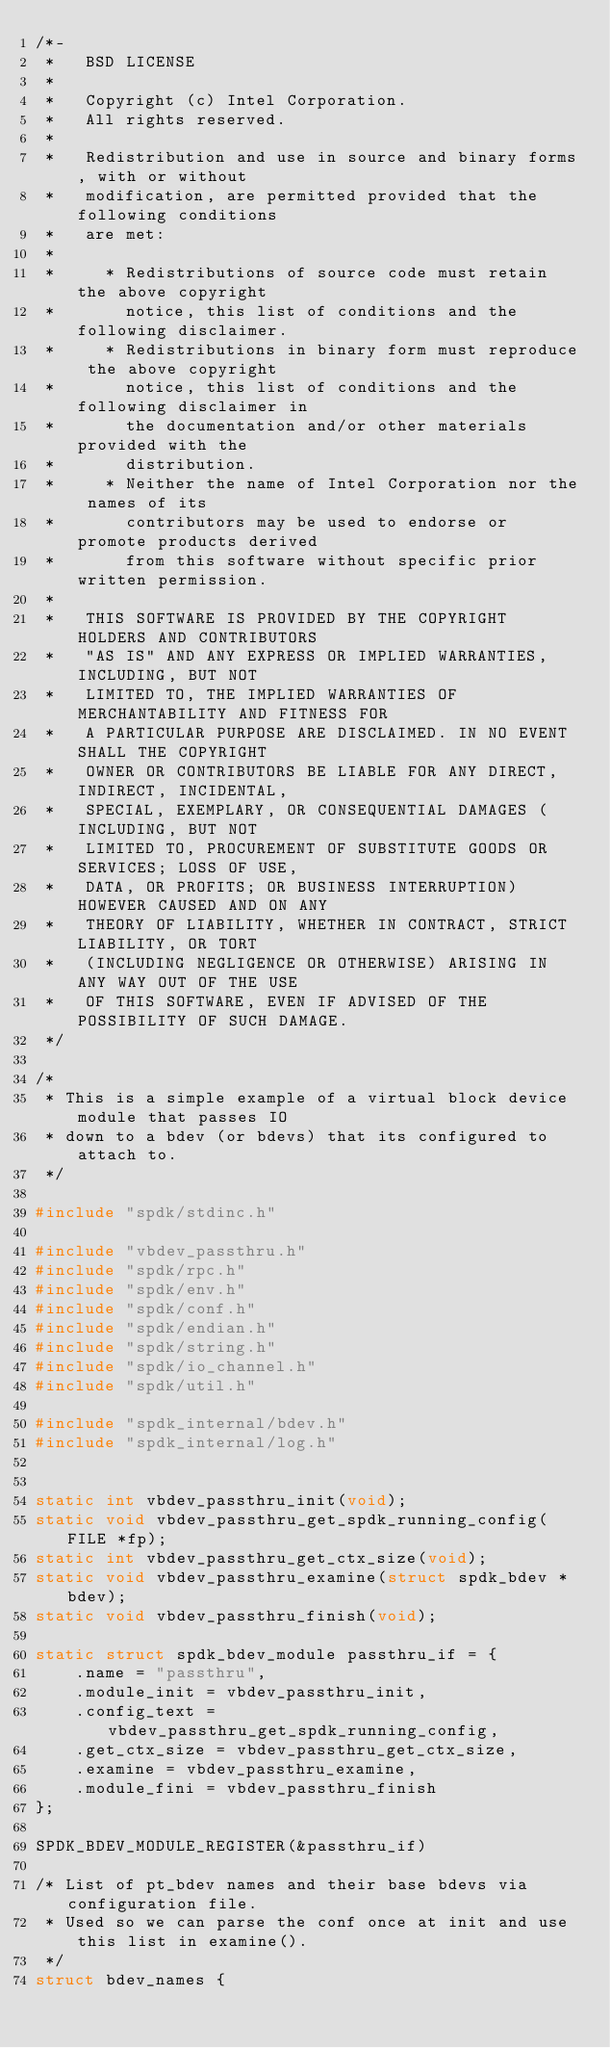Convert code to text. <code><loc_0><loc_0><loc_500><loc_500><_C_>/*-
 *   BSD LICENSE
 *
 *   Copyright (c) Intel Corporation.
 *   All rights reserved.
 *
 *   Redistribution and use in source and binary forms, with or without
 *   modification, are permitted provided that the following conditions
 *   are met:
 *
 *     * Redistributions of source code must retain the above copyright
 *       notice, this list of conditions and the following disclaimer.
 *     * Redistributions in binary form must reproduce the above copyright
 *       notice, this list of conditions and the following disclaimer in
 *       the documentation and/or other materials provided with the
 *       distribution.
 *     * Neither the name of Intel Corporation nor the names of its
 *       contributors may be used to endorse or promote products derived
 *       from this software without specific prior written permission.
 *
 *   THIS SOFTWARE IS PROVIDED BY THE COPYRIGHT HOLDERS AND CONTRIBUTORS
 *   "AS IS" AND ANY EXPRESS OR IMPLIED WARRANTIES, INCLUDING, BUT NOT
 *   LIMITED TO, THE IMPLIED WARRANTIES OF MERCHANTABILITY AND FITNESS FOR
 *   A PARTICULAR PURPOSE ARE DISCLAIMED. IN NO EVENT SHALL THE COPYRIGHT
 *   OWNER OR CONTRIBUTORS BE LIABLE FOR ANY DIRECT, INDIRECT, INCIDENTAL,
 *   SPECIAL, EXEMPLARY, OR CONSEQUENTIAL DAMAGES (INCLUDING, BUT NOT
 *   LIMITED TO, PROCUREMENT OF SUBSTITUTE GOODS OR SERVICES; LOSS OF USE,
 *   DATA, OR PROFITS; OR BUSINESS INTERRUPTION) HOWEVER CAUSED AND ON ANY
 *   THEORY OF LIABILITY, WHETHER IN CONTRACT, STRICT LIABILITY, OR TORT
 *   (INCLUDING NEGLIGENCE OR OTHERWISE) ARISING IN ANY WAY OUT OF THE USE
 *   OF THIS SOFTWARE, EVEN IF ADVISED OF THE POSSIBILITY OF SUCH DAMAGE.
 */

/*
 * This is a simple example of a virtual block device module that passes IO
 * down to a bdev (or bdevs) that its configured to attach to.
 */

#include "spdk/stdinc.h"

#include "vbdev_passthru.h"
#include "spdk/rpc.h"
#include "spdk/env.h"
#include "spdk/conf.h"
#include "spdk/endian.h"
#include "spdk/string.h"
#include "spdk/io_channel.h"
#include "spdk/util.h"

#include "spdk_internal/bdev.h"
#include "spdk_internal/log.h"


static int vbdev_passthru_init(void);
static void vbdev_passthru_get_spdk_running_config(FILE *fp);
static int vbdev_passthru_get_ctx_size(void);
static void vbdev_passthru_examine(struct spdk_bdev *bdev);
static void vbdev_passthru_finish(void);

static struct spdk_bdev_module passthru_if = {
	.name = "passthru",
	.module_init = vbdev_passthru_init,
	.config_text = vbdev_passthru_get_spdk_running_config,
	.get_ctx_size = vbdev_passthru_get_ctx_size,
	.examine = vbdev_passthru_examine,
	.module_fini = vbdev_passthru_finish
};

SPDK_BDEV_MODULE_REGISTER(&passthru_if)

/* List of pt_bdev names and their base bdevs via configuration file.
 * Used so we can parse the conf once at init and use this list in examine().
 */
struct bdev_names {</code> 